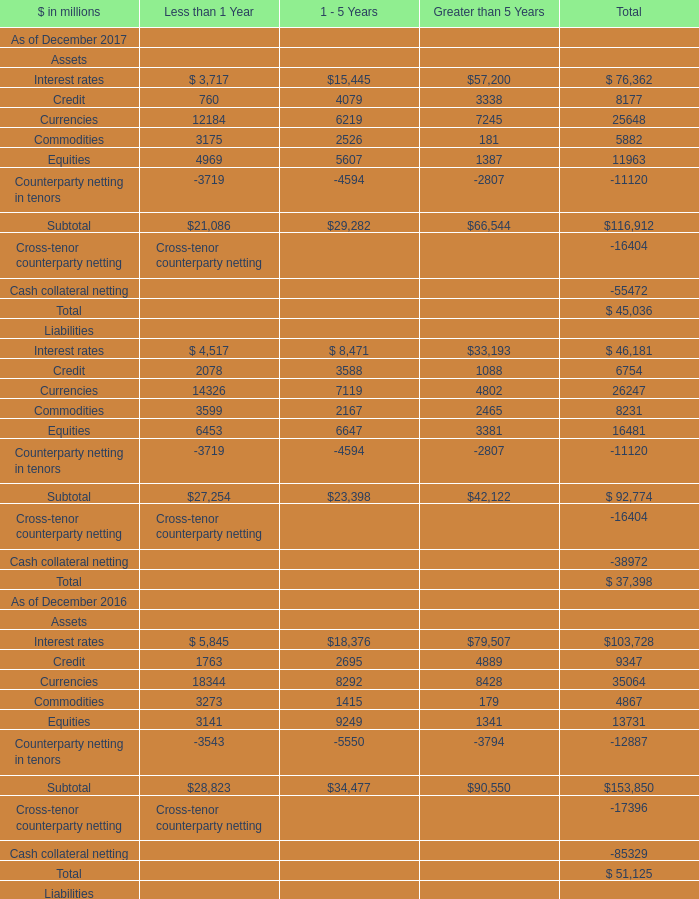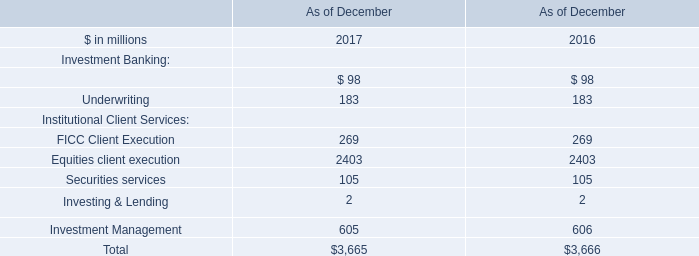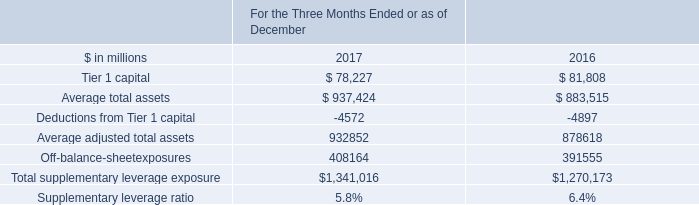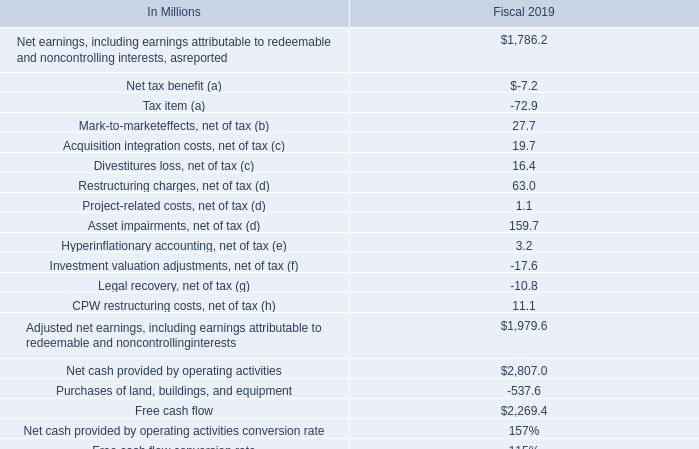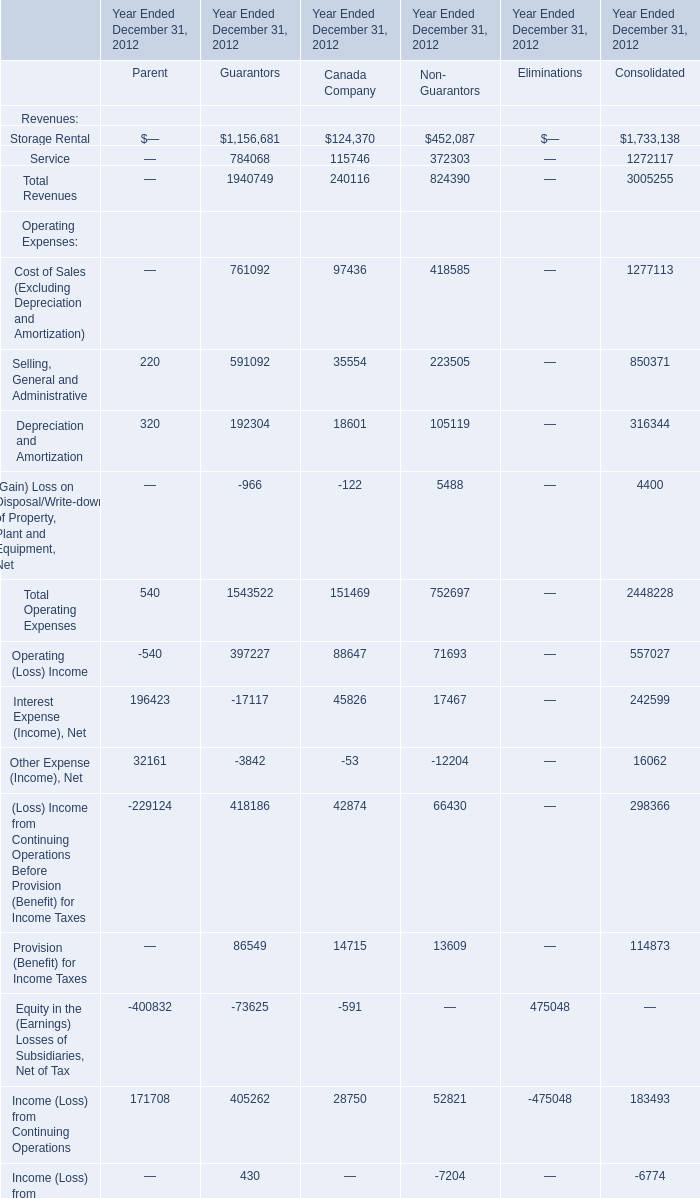What is the ratio of Assets Credit to the total in 2017? 
Computations: (8177 / 45036)
Answer: 0.18157. 